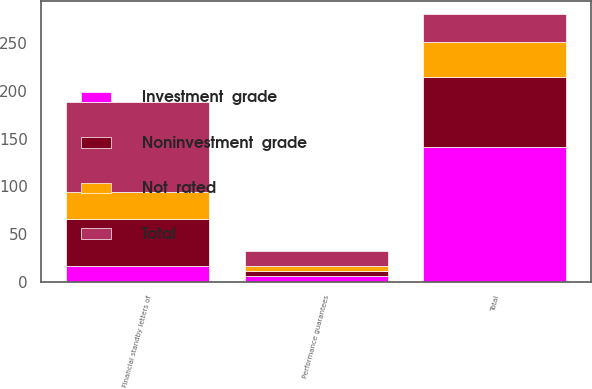Convert chart. <chart><loc_0><loc_0><loc_500><loc_500><stacked_bar_chart><ecel><fcel>Financial standby letters of<fcel>Performance guarantees<fcel>Total<nl><fcel>Noninvestment  grade<fcel>49.2<fcel>5.7<fcel>73.4<nl><fcel>Not  rated<fcel>28.6<fcel>5<fcel>36.7<nl><fcel>Investment  grade<fcel>16.4<fcel>5.6<fcel>141.7<nl><fcel>Total<fcel>94.2<fcel>16.3<fcel>28.6<nl></chart> 